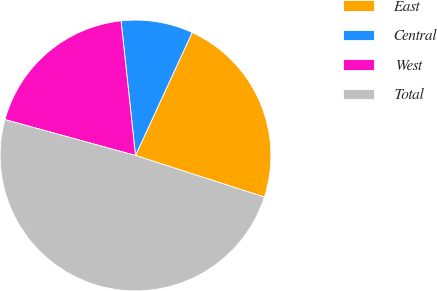Convert chart. <chart><loc_0><loc_0><loc_500><loc_500><pie_chart><fcel>East<fcel>Central<fcel>West<fcel>Total<nl><fcel>23.1%<fcel>8.57%<fcel>19.03%<fcel>49.3%<nl></chart> 